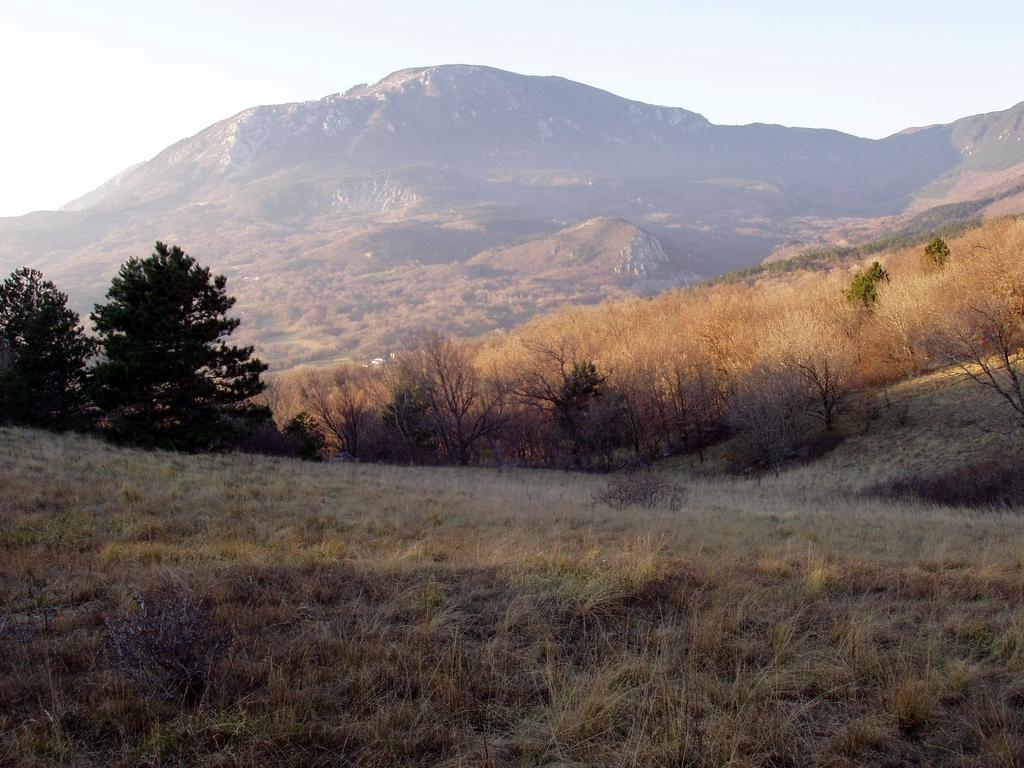What type of terrain is visible in the image? The image contains land full of dry grass. Where are the trees located in the image? The trees are on the left side of the image. What can be seen in the distance in the image? There is a mountain in the background of the image. What color is the throat of the person in the image? There is no person present in the image, so it is not possible to determine the color of their throat. 